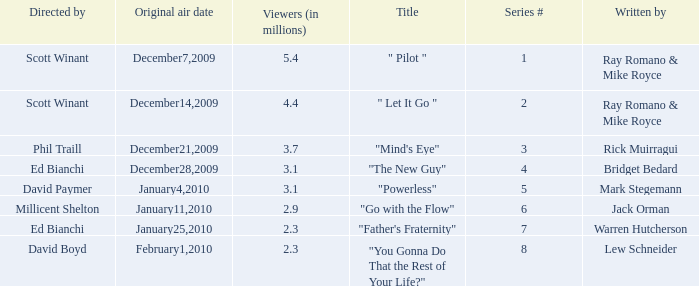What is the episode number of  "you gonna do that the rest of your life?" 8.0. 